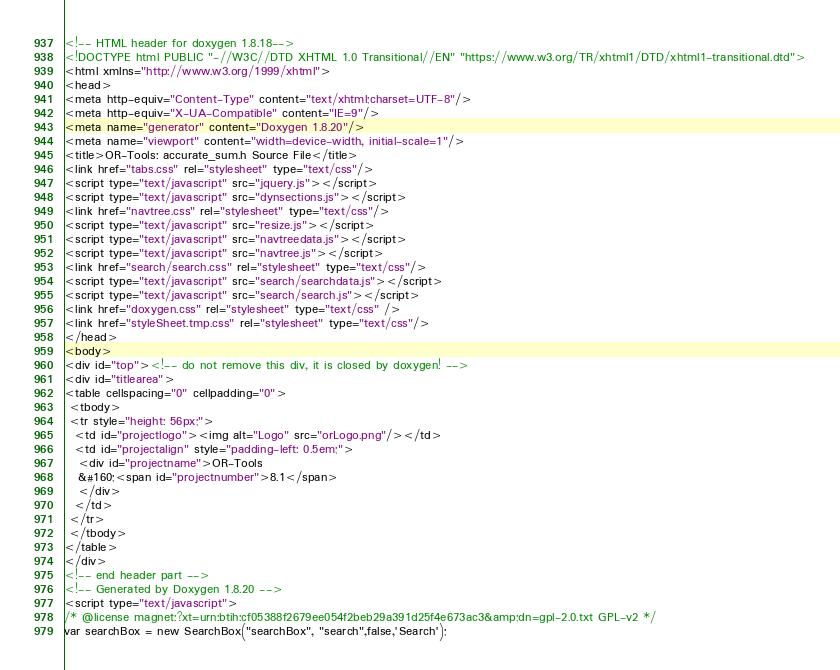Convert code to text. <code><loc_0><loc_0><loc_500><loc_500><_HTML_><!-- HTML header for doxygen 1.8.18-->
<!DOCTYPE html PUBLIC "-//W3C//DTD XHTML 1.0 Transitional//EN" "https://www.w3.org/TR/xhtml1/DTD/xhtml1-transitional.dtd">
<html xmlns="http://www.w3.org/1999/xhtml">
<head>
<meta http-equiv="Content-Type" content="text/xhtml;charset=UTF-8"/>
<meta http-equiv="X-UA-Compatible" content="IE=9"/>
<meta name="generator" content="Doxygen 1.8.20"/>
<meta name="viewport" content="width=device-width, initial-scale=1"/>
<title>OR-Tools: accurate_sum.h Source File</title>
<link href="tabs.css" rel="stylesheet" type="text/css"/>
<script type="text/javascript" src="jquery.js"></script>
<script type="text/javascript" src="dynsections.js"></script>
<link href="navtree.css" rel="stylesheet" type="text/css"/>
<script type="text/javascript" src="resize.js"></script>
<script type="text/javascript" src="navtreedata.js"></script>
<script type="text/javascript" src="navtree.js"></script>
<link href="search/search.css" rel="stylesheet" type="text/css"/>
<script type="text/javascript" src="search/searchdata.js"></script>
<script type="text/javascript" src="search/search.js"></script>
<link href="doxygen.css" rel="stylesheet" type="text/css" />
<link href="styleSheet.tmp.css" rel="stylesheet" type="text/css"/>
</head>
<body>
<div id="top"><!-- do not remove this div, it is closed by doxygen! -->
<div id="titlearea">
<table cellspacing="0" cellpadding="0">
 <tbody>
 <tr style="height: 56px;">
  <td id="projectlogo"><img alt="Logo" src="orLogo.png"/></td>
  <td id="projectalign" style="padding-left: 0.5em;">
   <div id="projectname">OR-Tools
   &#160;<span id="projectnumber">8.1</span>
   </div>
  </td>
 </tr>
 </tbody>
</table>
</div>
<!-- end header part -->
<!-- Generated by Doxygen 1.8.20 -->
<script type="text/javascript">
/* @license magnet:?xt=urn:btih:cf05388f2679ee054f2beb29a391d25f4e673ac3&amp;dn=gpl-2.0.txt GPL-v2 */
var searchBox = new SearchBox("searchBox", "search",false,'Search');</code> 